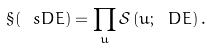<formula> <loc_0><loc_0><loc_500><loc_500>\S ( \ s D E ) = \prod _ { u } \mathcal { S } \left ( u ; \ D E \right ) .</formula> 